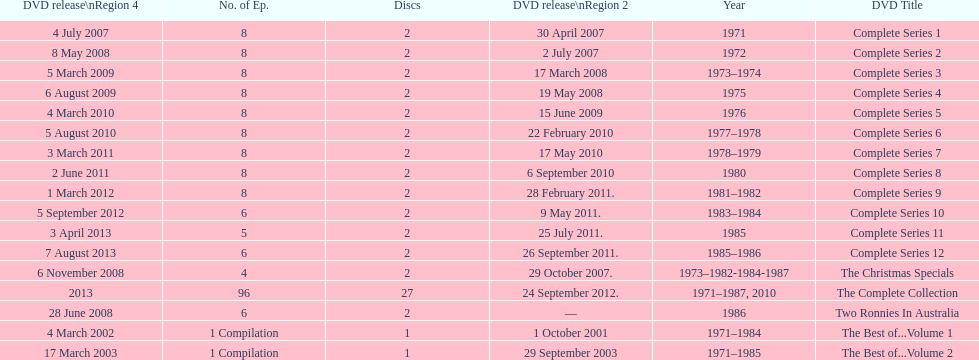Dvd shorter than 5 episodes The Christmas Specials. 